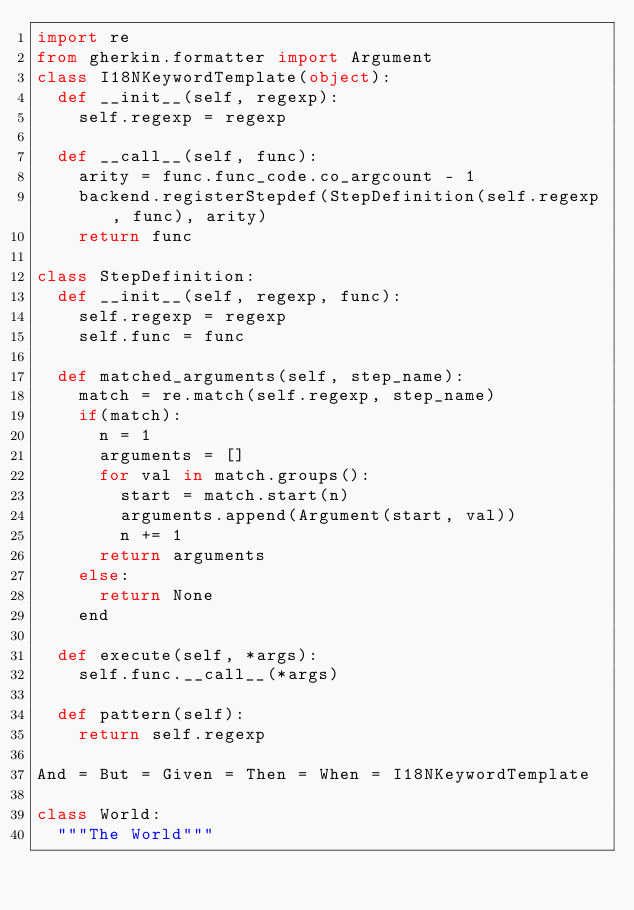<code> <loc_0><loc_0><loc_500><loc_500><_Python_>import re
from gherkin.formatter import Argument
class I18NKeywordTemplate(object):
  def __init__(self, regexp):
    self.regexp = regexp
    
  def __call__(self, func):
    arity = func.func_code.co_argcount - 1
    backend.registerStepdef(StepDefinition(self.regexp, func), arity)
    return func

class StepDefinition:
  def __init__(self, regexp, func):
    self.regexp = regexp
    self.func = func

  def matched_arguments(self, step_name):
    match = re.match(self.regexp, step_name)
    if(match):
      n = 1
      arguments = []
      for val in match.groups():
        start = match.start(n)
        arguments.append(Argument(start, val))
        n += 1
      return arguments
    else:
      return None
    end

  def execute(self, *args):
    self.func.__call__(*args)

  def pattern(self):
    return self.regexp

And = But = Given = Then = When = I18NKeywordTemplate

class World:
  """The World"""
</code> 